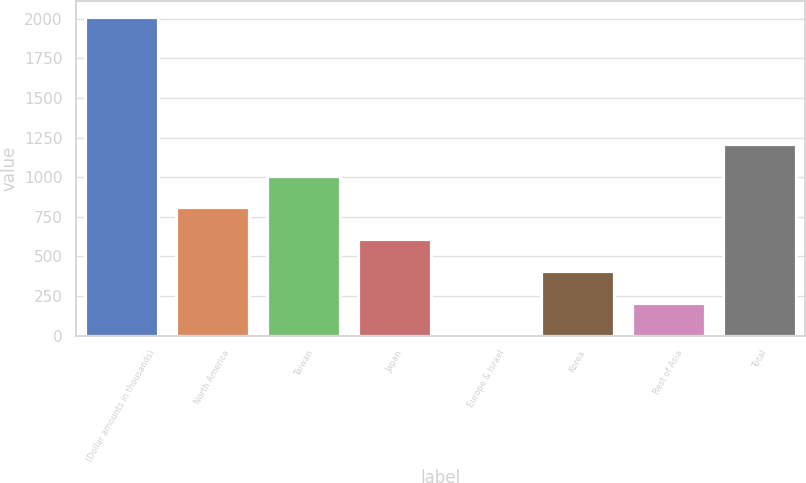<chart> <loc_0><loc_0><loc_500><loc_500><bar_chart><fcel>(Dollar amounts in thousands)<fcel>North America<fcel>Taiwan<fcel>Japan<fcel>Europe & Israel<fcel>Korea<fcel>Rest of Asia<fcel>Total<nl><fcel>2013<fcel>809.4<fcel>1010<fcel>608.8<fcel>7<fcel>408.2<fcel>207.6<fcel>1210.6<nl></chart> 